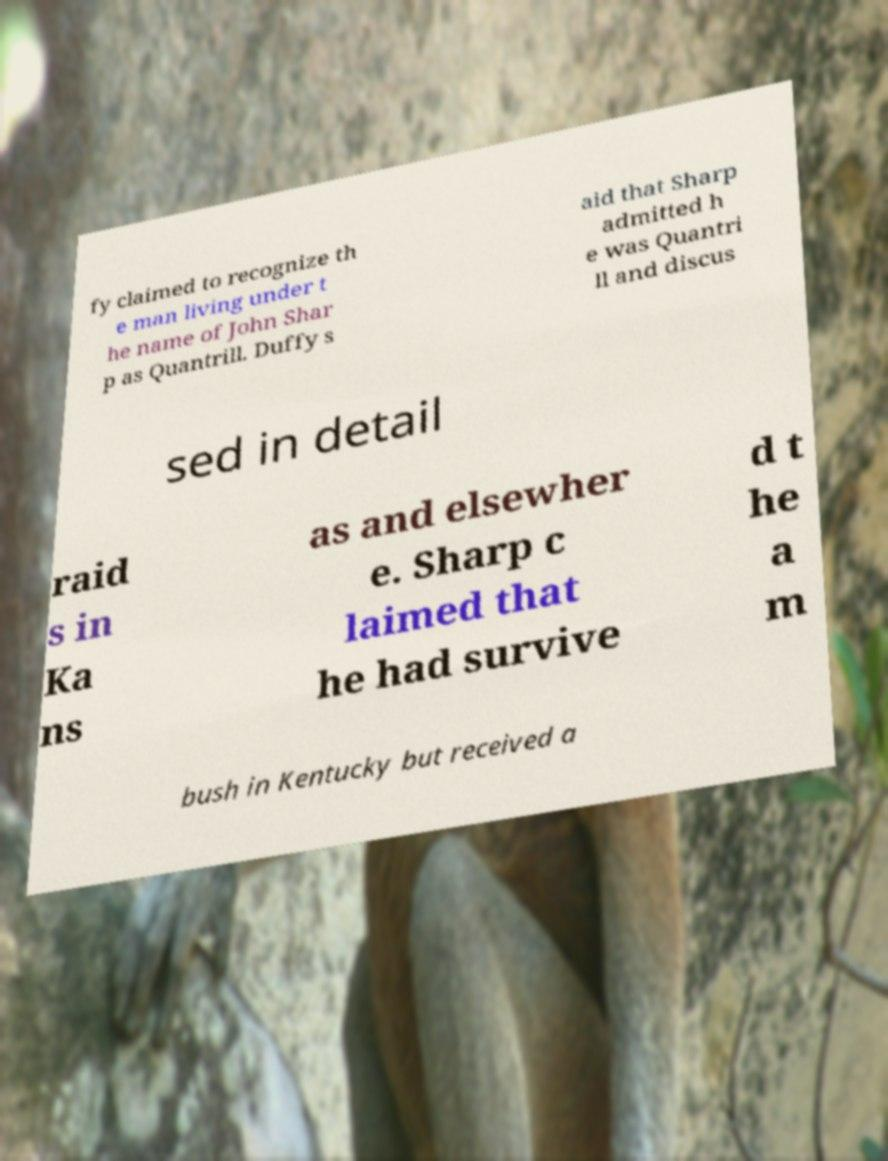Could you assist in decoding the text presented in this image and type it out clearly? fy claimed to recognize th e man living under t he name of John Shar p as Quantrill. Duffy s aid that Sharp admitted h e was Quantri ll and discus sed in detail raid s in Ka ns as and elsewher e. Sharp c laimed that he had survive d t he a m bush in Kentucky but received a 